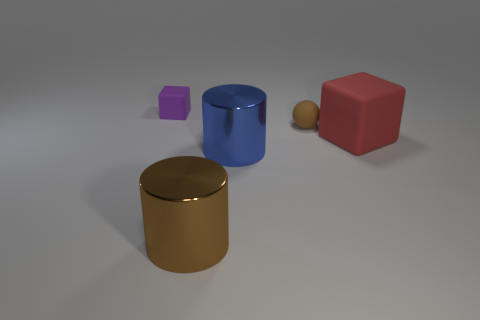Add 2 large blue things. How many objects exist? 7 Subtract all purple cubes. How many cubes are left? 1 Subtract all spheres. How many objects are left? 4 Add 3 large rubber objects. How many large rubber objects exist? 4 Subtract 1 blue cylinders. How many objects are left? 4 Subtract all yellow cubes. Subtract all blue spheres. How many cubes are left? 2 Subtract all tiny things. Subtract all small brown balls. How many objects are left? 2 Add 1 large metal objects. How many large metal objects are left? 3 